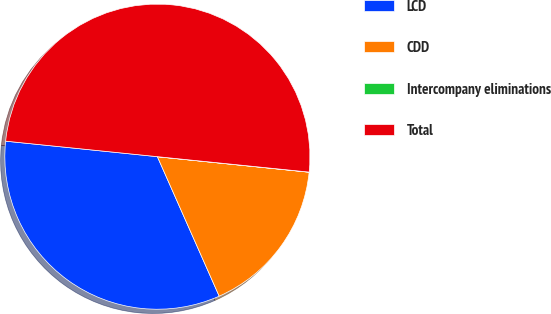<chart> <loc_0><loc_0><loc_500><loc_500><pie_chart><fcel>LCD<fcel>CDD<fcel>Intercompany eliminations<fcel>Total<nl><fcel>33.26%<fcel>16.74%<fcel>0.01%<fcel>49.99%<nl></chart> 